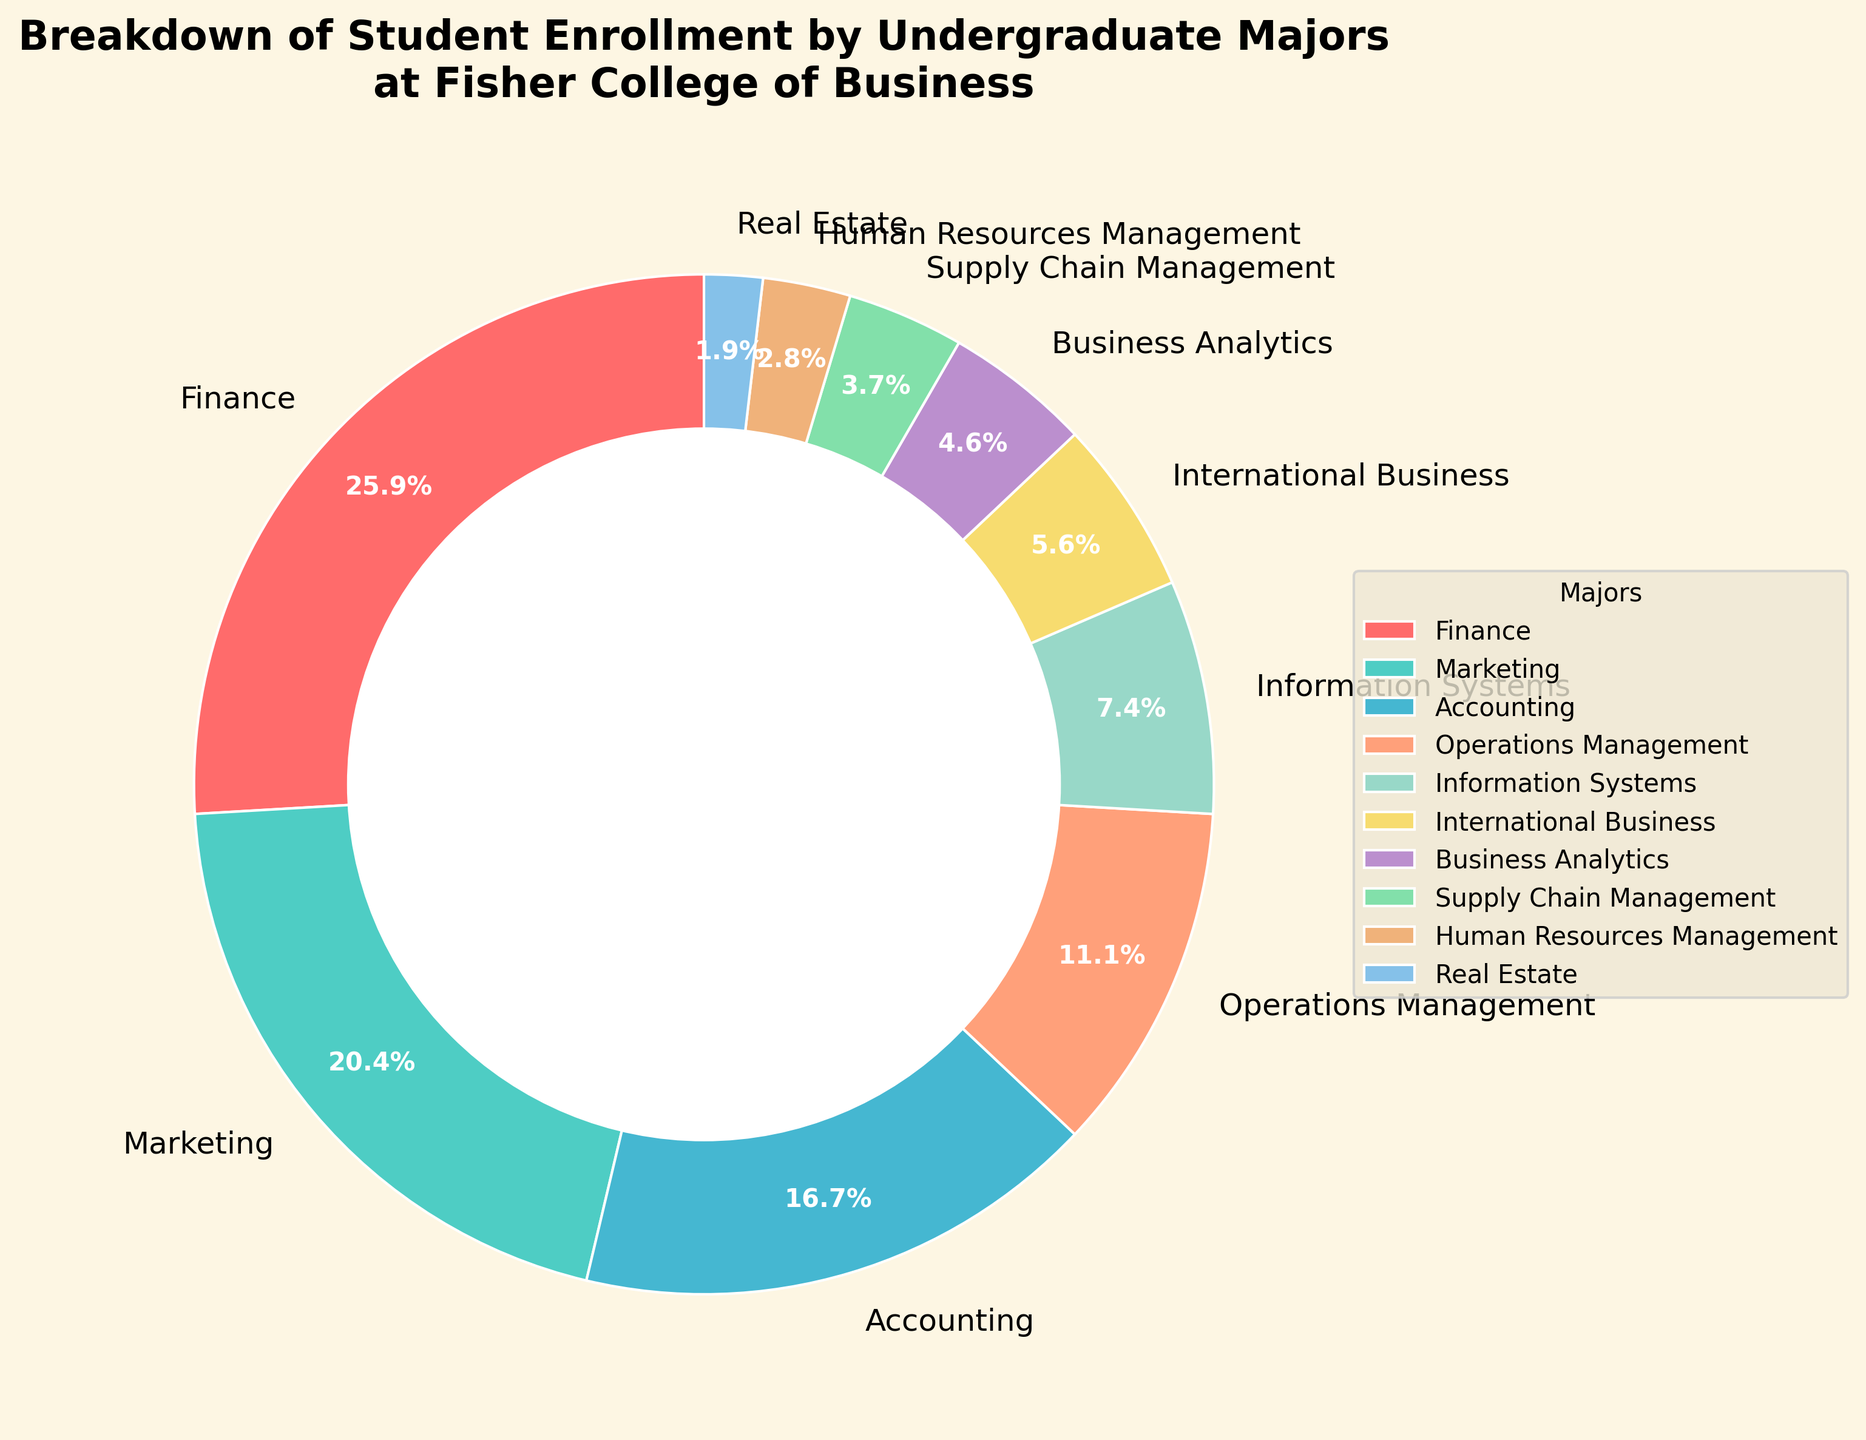What's the most popular major at Fisher College of Business? By looking at the size of the wedges in the pie chart, the largest wedge represents Finance.
Answer: Finance Which major has the smallest enrollment? The smallest section of the pie chart represents Real Estate.
Answer: Real Estate How many more students are enrolled in Finance compared to Information Systems? Finance has 28 students and Information Systems has 8, so the difference is 28 - 8 = 20.
Answer: 20 What is the combined percentage of students enrolled in Operations Management and Business Analytics? Operations Management is 12% and Business Analytics is 5%, so combined they are 12% + 5% = 17%.
Answer: 17% Which is greater, the number of students in Marketing or the sum of students in Supply Chain Management and Real Estate? Marketing has 22 students, Supply Chain Management has 4, and Real Estate has 2. The combined sum is 4 + 2 = 6, which is less than 22.
Answer: Marketing What color represents the Marketing major in the pie chart? Looking at the chart, the Marketing section has been assigned a distinct green color.
Answer: Green How does the enrollment in Accounting compare to the enrollment in Business Analytics? Accounting has 18 students, whereas Business Analytics has 5. Therefore, Accounting has more students.
Answer: Accounting What's the combined enrollment for Operations Management, Information Systems, and International Business? The numbers are 12, 8, and 6, respectively. Adding them gives 12 + 8 + 6 = 26.
Answer: 26 If we were to combine the enrollments of Human Resources Management and Real Estate, would their total be closer to the enrollment of Operations Management or Supply Chain Management? Human Resources Management has 3 students and Real Estate has 2, so their combined total is 3 + 2 = 5. This is closer to Supply Chain Management, which has 4 students, than it is to Operations Management with 12 students.
Answer: Supply Chain Management Out of the listed majors, which one occupies the second largest section of the pie chart? After Finance, the next largest section represents Marketing.
Answer: Marketing 